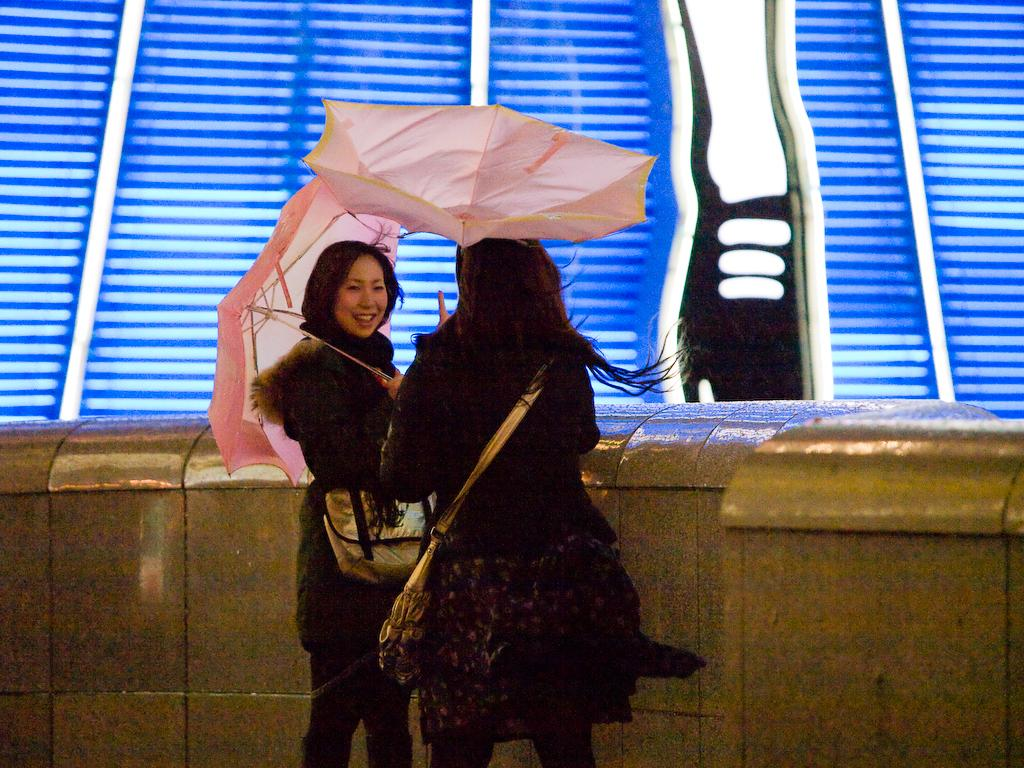How many people are in the image? There are two ladies in the image. What are the ladies wearing that are visible in the image? The ladies are wearing bags. What are the ladies holding in the image? The ladies are holding umbrellas. What is near the ladies in the image? There is a wall near the ladies. What colors can be seen on the wall in the background of the image? The wall in the background has blue and white colors. What type of cow can be seen grazing near the ladies in the image? There is no cow present in the image; it features two ladies holding umbrellas and wearing bags. What color are the crayons that the ladies are using in the image? There are no crayons present in the image; the ladies are holding umbrellas and wearing bags. 